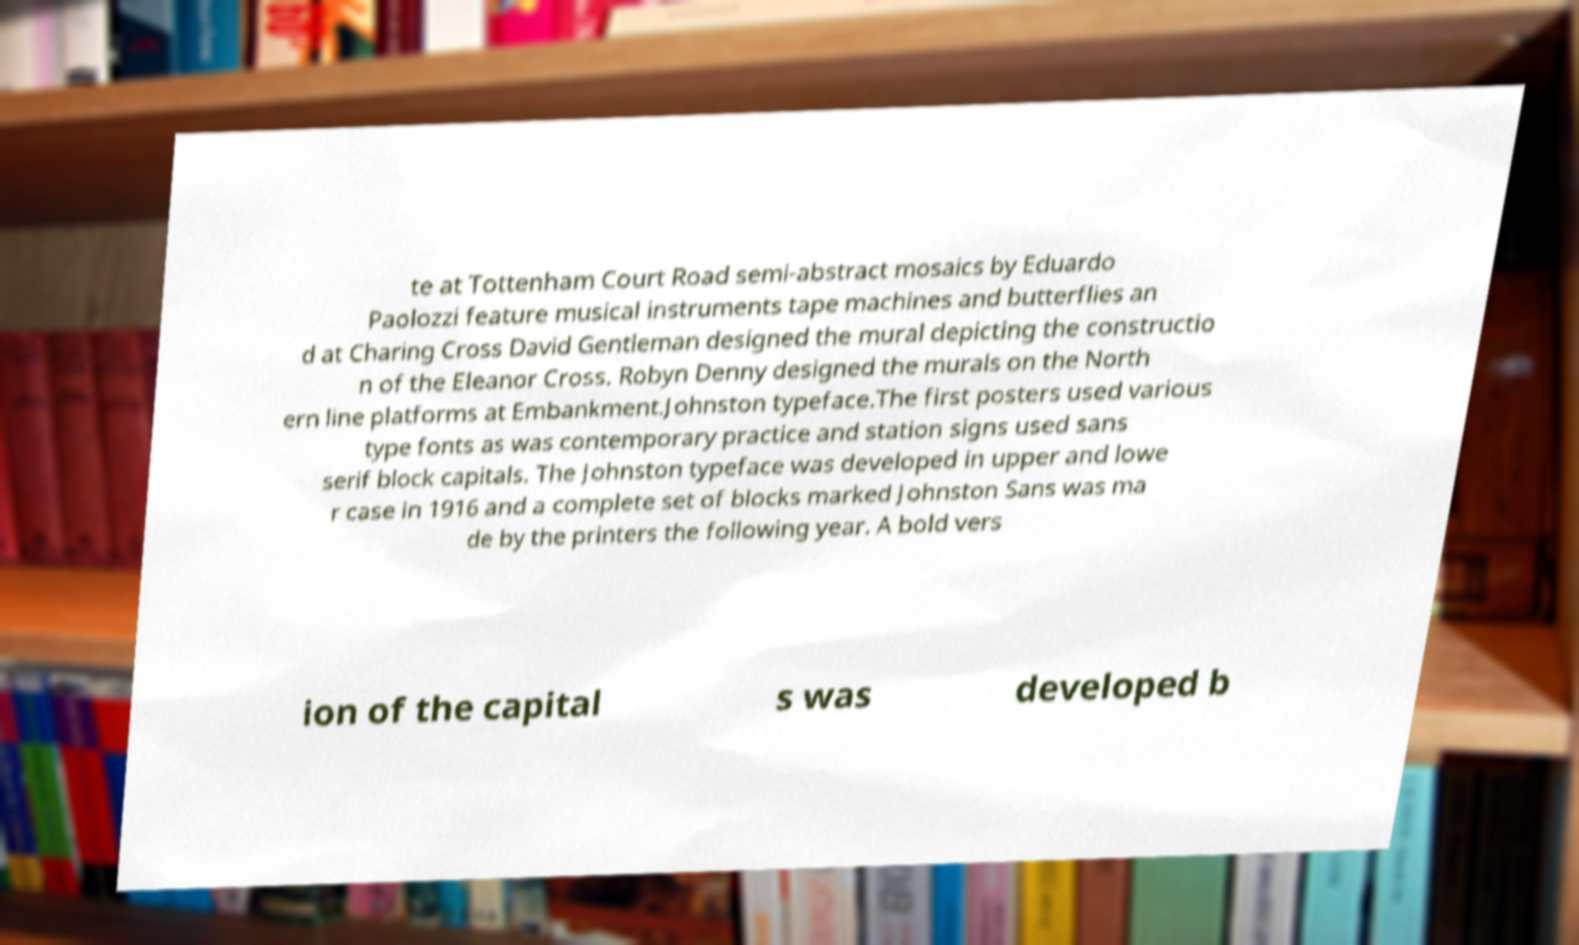For documentation purposes, I need the text within this image transcribed. Could you provide that? te at Tottenham Court Road semi-abstract mosaics by Eduardo Paolozzi feature musical instruments tape machines and butterflies an d at Charing Cross David Gentleman designed the mural depicting the constructio n of the Eleanor Cross. Robyn Denny designed the murals on the North ern line platforms at Embankment.Johnston typeface.The first posters used various type fonts as was contemporary practice and station signs used sans serif block capitals. The Johnston typeface was developed in upper and lowe r case in 1916 and a complete set of blocks marked Johnston Sans was ma de by the printers the following year. A bold vers ion of the capital s was developed b 